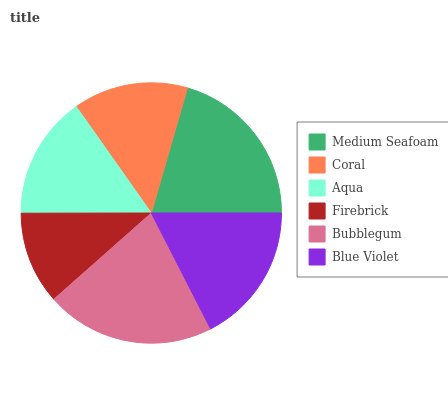Is Firebrick the minimum?
Answer yes or no. Yes. Is Bubblegum the maximum?
Answer yes or no. Yes. Is Coral the minimum?
Answer yes or no. No. Is Coral the maximum?
Answer yes or no. No. Is Medium Seafoam greater than Coral?
Answer yes or no. Yes. Is Coral less than Medium Seafoam?
Answer yes or no. Yes. Is Coral greater than Medium Seafoam?
Answer yes or no. No. Is Medium Seafoam less than Coral?
Answer yes or no. No. Is Blue Violet the high median?
Answer yes or no. Yes. Is Aqua the low median?
Answer yes or no. Yes. Is Medium Seafoam the high median?
Answer yes or no. No. Is Medium Seafoam the low median?
Answer yes or no. No. 